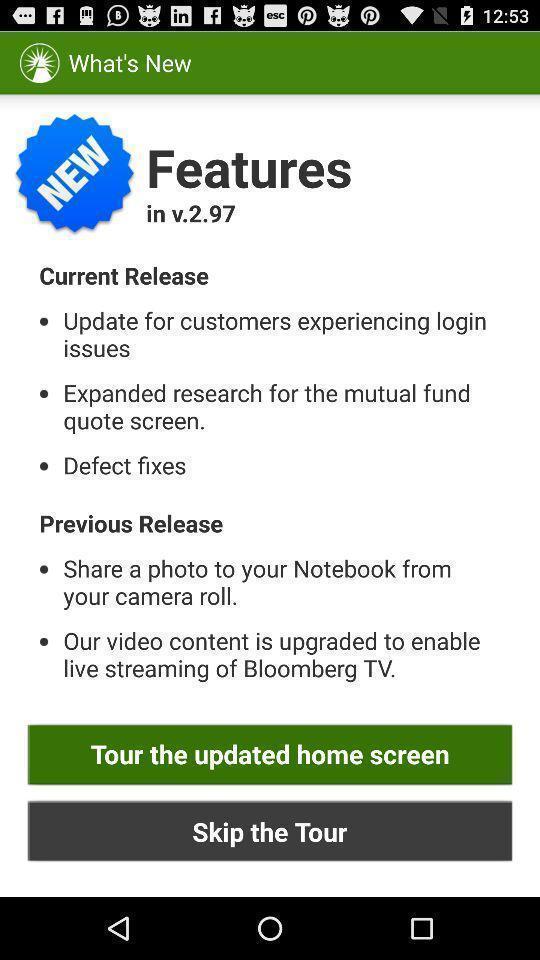Tell me about the visual elements in this screen capture. Screen display new features. 